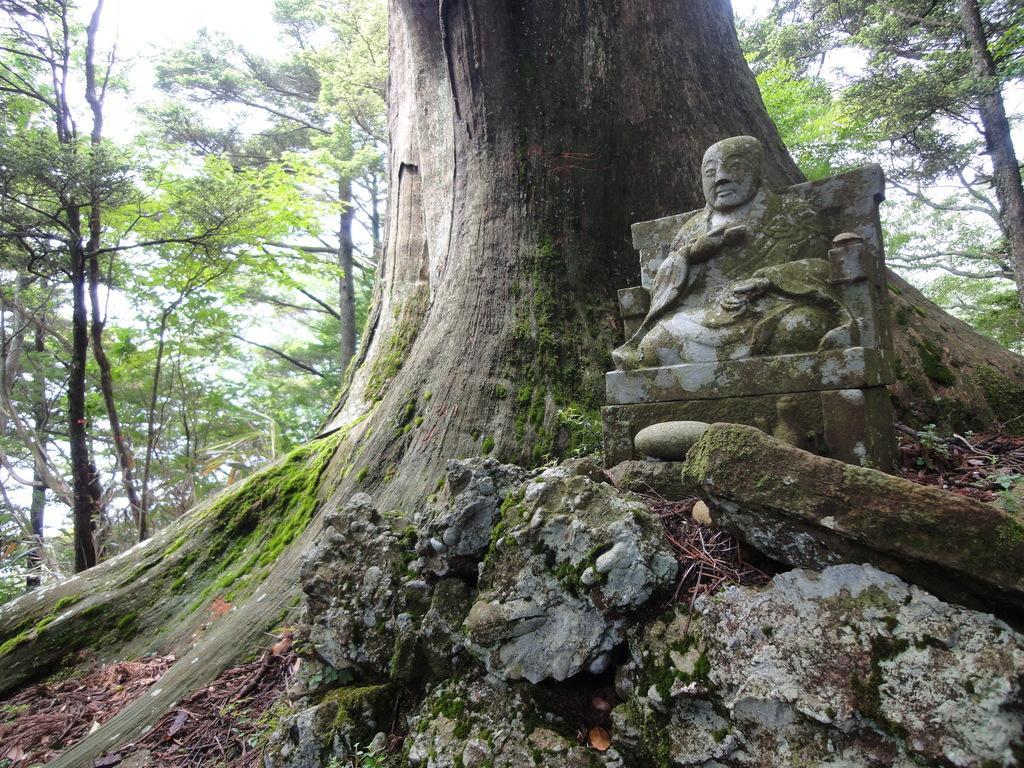In one or two sentences, can you explain what this image depicts? In this image in the front there is a sculpture and there is a tree trunk. In the background there are trees. 